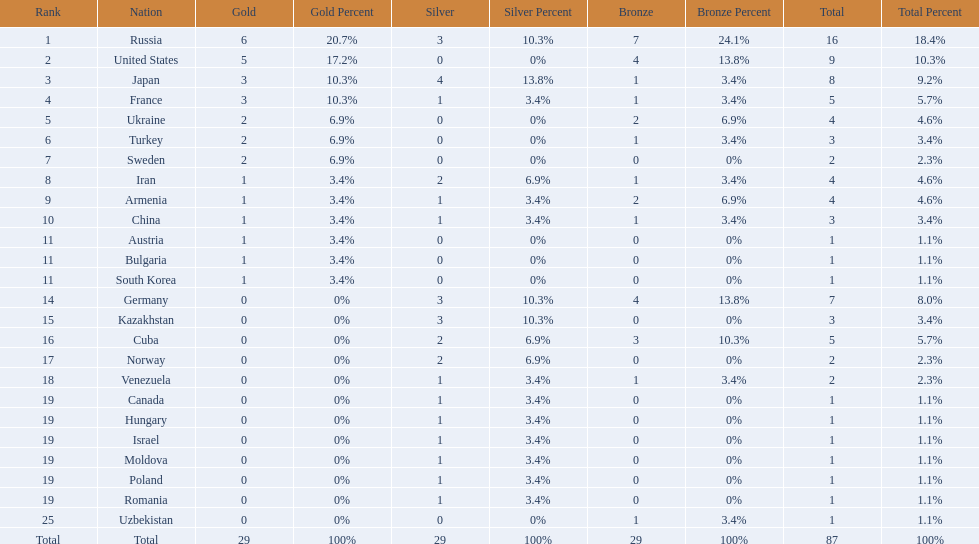Where did iran rank? 8. Where did germany rank? 14. Which of those did make it into the top 10 rank? Germany. 